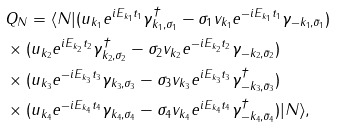<formula> <loc_0><loc_0><loc_500><loc_500>& Q _ { N } = \langle N | ( u _ { k _ { 1 } } e ^ { i E _ { k _ { 1 } } t _ { 1 } } \gamma _ { k _ { 1 } , \sigma _ { 1 } } ^ { \dagger } - \sigma _ { 1 } v _ { k _ { 1 } } e ^ { - i E _ { k _ { 1 } } t _ { 1 } } \gamma _ { - k _ { 1 } , \bar { \sigma } _ { 1 } } ) \\ & \times ( u _ { k _ { 2 } } e ^ { i E _ { k _ { 2 } } t _ { 2 } } \gamma _ { k _ { 2 } , \sigma _ { 2 } } ^ { \dagger } - \sigma _ { 2 } v _ { k _ { 2 } } e ^ { - i E _ { k _ { 2 } } t _ { 2 } } \gamma _ { - k _ { 2 } , \bar { \sigma } _ { 2 } } ) \\ & \times ( u _ { k _ { 3 } } e ^ { - i E _ { k _ { 3 } } t _ { 3 } } \gamma _ { k _ { 3 } , \sigma _ { 3 } } - \sigma _ { 3 } v _ { k _ { 3 } } e ^ { i E _ { k _ { 3 } } t _ { 3 } } \gamma _ { - k _ { 3 } , \bar { \sigma } _ { 3 } } ^ { \dagger } ) \\ & \times ( u _ { k _ { 4 } } e ^ { - i E _ { k _ { 4 } } t _ { 4 } } \gamma _ { k _ { 4 } , \sigma _ { 4 } } - \sigma _ { 4 } v _ { k _ { 4 } } e ^ { i E _ { k _ { 4 } } t _ { 4 } } \gamma _ { - k _ { 4 } , \bar { \sigma } _ { 4 } } ^ { \dagger } ) | N \rangle ,</formula> 